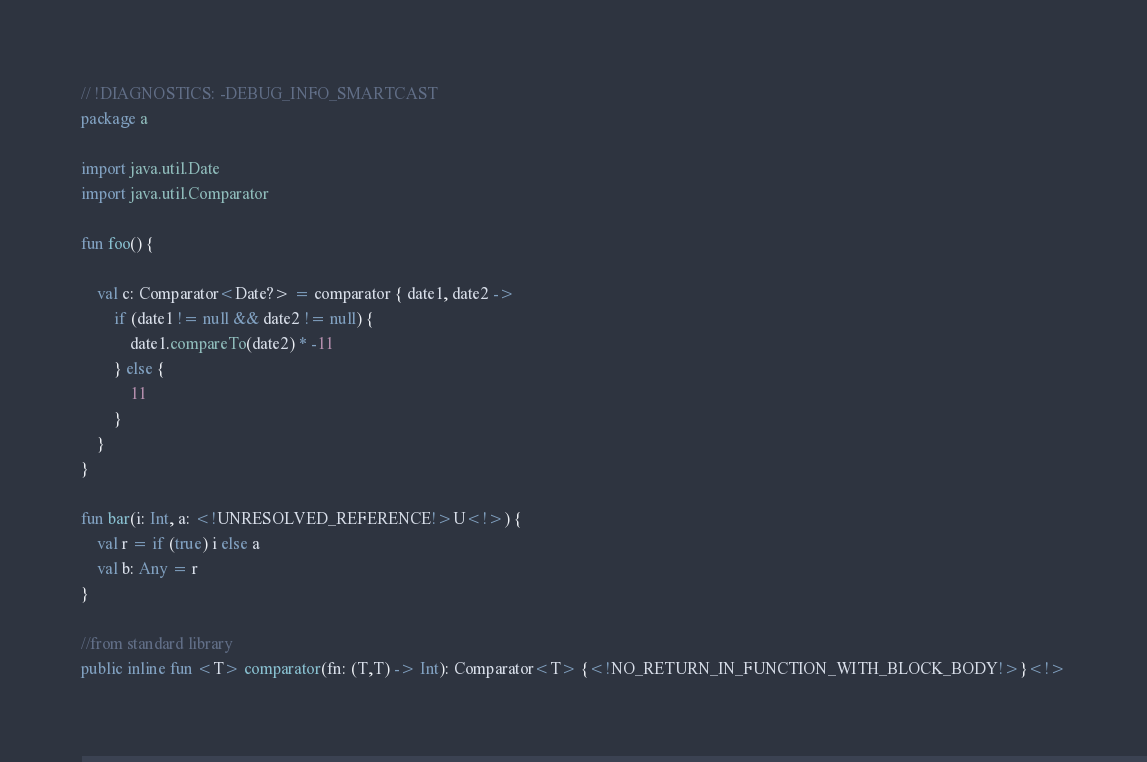<code> <loc_0><loc_0><loc_500><loc_500><_Kotlin_>// !DIAGNOSTICS: -DEBUG_INFO_SMARTCAST
package a

import java.util.Date
import java.util.Comparator

fun foo() {

    val c: Comparator<Date?> = comparator { date1, date2 ->
        if (date1 != null && date2 != null) {
            date1.compareTo(date2) * -11
        } else {
            11
        }
    }
}

fun bar(i: Int, a: <!UNRESOLVED_REFERENCE!>U<!>) {
    val r = if (true) i else a
    val b: Any = r
}

//from standard library
public inline fun <T> comparator(fn: (T,T) -> Int): Comparator<T> {<!NO_RETURN_IN_FUNCTION_WITH_BLOCK_BODY!>}<!>
</code> 